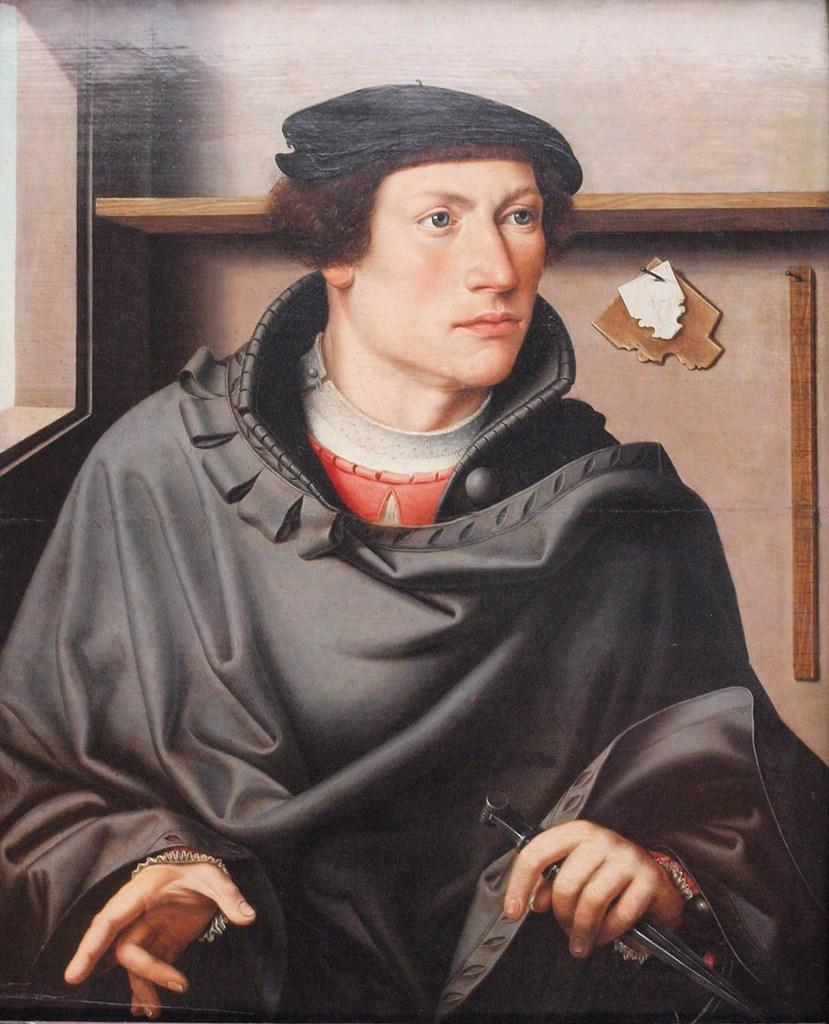What type of artwork is depicted in the image? The image appears to be a painting. Can you describe the person in the painting? There is a man in the painting, and he is wearing a black coat. What is the man doing in the painting? The man is sitting in the painting. What can be seen in the background of the painting? There is a wall and a wooden rack in the background of the painting. What type of rice is being cooked in the background of the painting? There is no rice present in the image; it is a painting of a man sitting with a wall and a wooden rack in the background. 